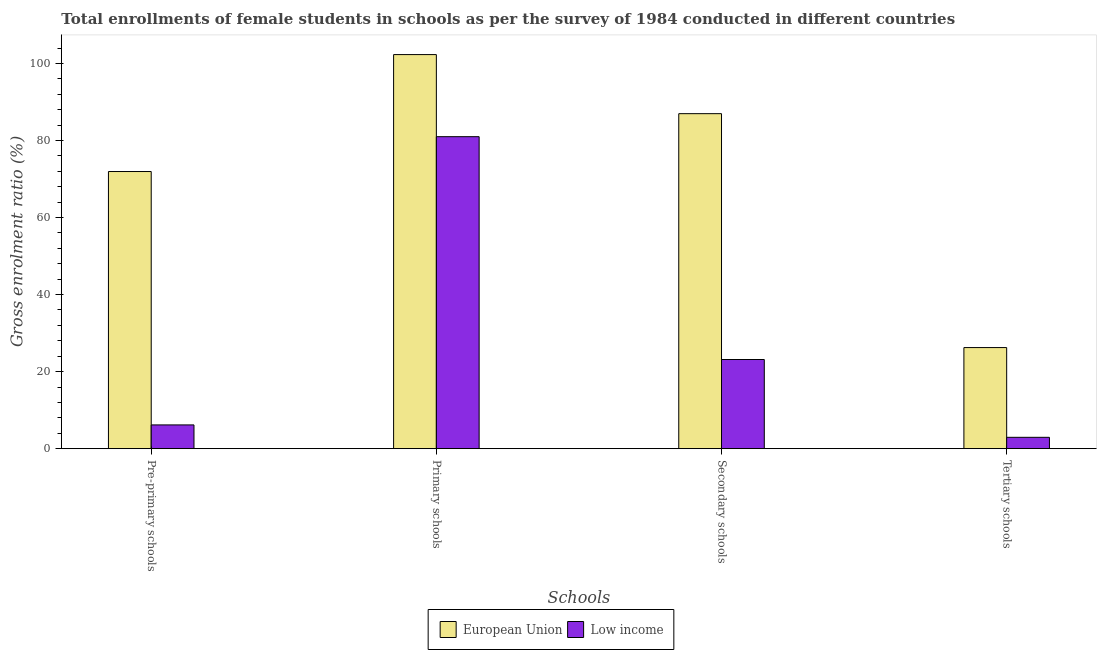Are the number of bars per tick equal to the number of legend labels?
Ensure brevity in your answer.  Yes. Are the number of bars on each tick of the X-axis equal?
Offer a terse response. Yes. What is the label of the 4th group of bars from the left?
Offer a very short reply. Tertiary schools. What is the gross enrolment ratio(female) in secondary schools in European Union?
Make the answer very short. 86.96. Across all countries, what is the maximum gross enrolment ratio(female) in tertiary schools?
Give a very brief answer. 26.24. Across all countries, what is the minimum gross enrolment ratio(female) in pre-primary schools?
Provide a short and direct response. 6.17. In which country was the gross enrolment ratio(female) in tertiary schools maximum?
Provide a short and direct response. European Union. In which country was the gross enrolment ratio(female) in secondary schools minimum?
Give a very brief answer. Low income. What is the total gross enrolment ratio(female) in primary schools in the graph?
Your response must be concise. 183.28. What is the difference between the gross enrolment ratio(female) in tertiary schools in European Union and that in Low income?
Provide a short and direct response. 23.3. What is the difference between the gross enrolment ratio(female) in pre-primary schools in European Union and the gross enrolment ratio(female) in primary schools in Low income?
Make the answer very short. -9.04. What is the average gross enrolment ratio(female) in primary schools per country?
Make the answer very short. 91.64. What is the difference between the gross enrolment ratio(female) in secondary schools and gross enrolment ratio(female) in pre-primary schools in European Union?
Offer a terse response. 15.02. What is the ratio of the gross enrolment ratio(female) in secondary schools in European Union to that in Low income?
Make the answer very short. 3.76. Is the difference between the gross enrolment ratio(female) in pre-primary schools in European Union and Low income greater than the difference between the gross enrolment ratio(female) in tertiary schools in European Union and Low income?
Offer a terse response. Yes. What is the difference between the highest and the second highest gross enrolment ratio(female) in secondary schools?
Your answer should be compact. 63.81. What is the difference between the highest and the lowest gross enrolment ratio(female) in tertiary schools?
Your response must be concise. 23.3. What does the 1st bar from the left in Primary schools represents?
Offer a terse response. European Union. Is it the case that in every country, the sum of the gross enrolment ratio(female) in pre-primary schools and gross enrolment ratio(female) in primary schools is greater than the gross enrolment ratio(female) in secondary schools?
Offer a very short reply. Yes. Are all the bars in the graph horizontal?
Give a very brief answer. No. What is the difference between two consecutive major ticks on the Y-axis?
Give a very brief answer. 20. Does the graph contain grids?
Offer a very short reply. No. Where does the legend appear in the graph?
Your answer should be very brief. Bottom center. How are the legend labels stacked?
Offer a very short reply. Horizontal. What is the title of the graph?
Provide a short and direct response. Total enrollments of female students in schools as per the survey of 1984 conducted in different countries. What is the label or title of the X-axis?
Provide a succinct answer. Schools. What is the label or title of the Y-axis?
Offer a very short reply. Gross enrolment ratio (%). What is the Gross enrolment ratio (%) of European Union in Pre-primary schools?
Ensure brevity in your answer.  71.94. What is the Gross enrolment ratio (%) in Low income in Pre-primary schools?
Ensure brevity in your answer.  6.17. What is the Gross enrolment ratio (%) in European Union in Primary schools?
Make the answer very short. 102.3. What is the Gross enrolment ratio (%) in Low income in Primary schools?
Provide a succinct answer. 80.98. What is the Gross enrolment ratio (%) of European Union in Secondary schools?
Offer a very short reply. 86.96. What is the Gross enrolment ratio (%) in Low income in Secondary schools?
Keep it short and to the point. 23.15. What is the Gross enrolment ratio (%) in European Union in Tertiary schools?
Offer a terse response. 26.24. What is the Gross enrolment ratio (%) in Low income in Tertiary schools?
Keep it short and to the point. 2.95. Across all Schools, what is the maximum Gross enrolment ratio (%) in European Union?
Ensure brevity in your answer.  102.3. Across all Schools, what is the maximum Gross enrolment ratio (%) of Low income?
Your answer should be very brief. 80.98. Across all Schools, what is the minimum Gross enrolment ratio (%) of European Union?
Your answer should be very brief. 26.24. Across all Schools, what is the minimum Gross enrolment ratio (%) of Low income?
Make the answer very short. 2.95. What is the total Gross enrolment ratio (%) in European Union in the graph?
Make the answer very short. 287.44. What is the total Gross enrolment ratio (%) of Low income in the graph?
Keep it short and to the point. 113.24. What is the difference between the Gross enrolment ratio (%) in European Union in Pre-primary schools and that in Primary schools?
Offer a terse response. -30.35. What is the difference between the Gross enrolment ratio (%) of Low income in Pre-primary schools and that in Primary schools?
Offer a very short reply. -74.82. What is the difference between the Gross enrolment ratio (%) of European Union in Pre-primary schools and that in Secondary schools?
Your answer should be very brief. -15.02. What is the difference between the Gross enrolment ratio (%) in Low income in Pre-primary schools and that in Secondary schools?
Provide a succinct answer. -16.98. What is the difference between the Gross enrolment ratio (%) in European Union in Pre-primary schools and that in Tertiary schools?
Keep it short and to the point. 45.7. What is the difference between the Gross enrolment ratio (%) of Low income in Pre-primary schools and that in Tertiary schools?
Give a very brief answer. 3.22. What is the difference between the Gross enrolment ratio (%) in European Union in Primary schools and that in Secondary schools?
Provide a short and direct response. 15.34. What is the difference between the Gross enrolment ratio (%) in Low income in Primary schools and that in Secondary schools?
Give a very brief answer. 57.84. What is the difference between the Gross enrolment ratio (%) in European Union in Primary schools and that in Tertiary schools?
Give a very brief answer. 76.05. What is the difference between the Gross enrolment ratio (%) in Low income in Primary schools and that in Tertiary schools?
Make the answer very short. 78.04. What is the difference between the Gross enrolment ratio (%) in European Union in Secondary schools and that in Tertiary schools?
Offer a terse response. 60.72. What is the difference between the Gross enrolment ratio (%) of Low income in Secondary schools and that in Tertiary schools?
Ensure brevity in your answer.  20.2. What is the difference between the Gross enrolment ratio (%) in European Union in Pre-primary schools and the Gross enrolment ratio (%) in Low income in Primary schools?
Offer a terse response. -9.04. What is the difference between the Gross enrolment ratio (%) of European Union in Pre-primary schools and the Gross enrolment ratio (%) of Low income in Secondary schools?
Provide a succinct answer. 48.8. What is the difference between the Gross enrolment ratio (%) in European Union in Pre-primary schools and the Gross enrolment ratio (%) in Low income in Tertiary schools?
Make the answer very short. 69. What is the difference between the Gross enrolment ratio (%) in European Union in Primary schools and the Gross enrolment ratio (%) in Low income in Secondary schools?
Your answer should be compact. 79.15. What is the difference between the Gross enrolment ratio (%) in European Union in Primary schools and the Gross enrolment ratio (%) in Low income in Tertiary schools?
Your answer should be very brief. 99.35. What is the difference between the Gross enrolment ratio (%) in European Union in Secondary schools and the Gross enrolment ratio (%) in Low income in Tertiary schools?
Make the answer very short. 84.01. What is the average Gross enrolment ratio (%) in European Union per Schools?
Keep it short and to the point. 71.86. What is the average Gross enrolment ratio (%) of Low income per Schools?
Provide a succinct answer. 28.31. What is the difference between the Gross enrolment ratio (%) in European Union and Gross enrolment ratio (%) in Low income in Pre-primary schools?
Offer a terse response. 65.77. What is the difference between the Gross enrolment ratio (%) of European Union and Gross enrolment ratio (%) of Low income in Primary schools?
Offer a very short reply. 21.31. What is the difference between the Gross enrolment ratio (%) of European Union and Gross enrolment ratio (%) of Low income in Secondary schools?
Your answer should be very brief. 63.81. What is the difference between the Gross enrolment ratio (%) in European Union and Gross enrolment ratio (%) in Low income in Tertiary schools?
Your response must be concise. 23.3. What is the ratio of the Gross enrolment ratio (%) of European Union in Pre-primary schools to that in Primary schools?
Provide a short and direct response. 0.7. What is the ratio of the Gross enrolment ratio (%) in Low income in Pre-primary schools to that in Primary schools?
Your answer should be very brief. 0.08. What is the ratio of the Gross enrolment ratio (%) of European Union in Pre-primary schools to that in Secondary schools?
Make the answer very short. 0.83. What is the ratio of the Gross enrolment ratio (%) in Low income in Pre-primary schools to that in Secondary schools?
Offer a terse response. 0.27. What is the ratio of the Gross enrolment ratio (%) of European Union in Pre-primary schools to that in Tertiary schools?
Your response must be concise. 2.74. What is the ratio of the Gross enrolment ratio (%) of Low income in Pre-primary schools to that in Tertiary schools?
Give a very brief answer. 2.09. What is the ratio of the Gross enrolment ratio (%) in European Union in Primary schools to that in Secondary schools?
Ensure brevity in your answer.  1.18. What is the ratio of the Gross enrolment ratio (%) of Low income in Primary schools to that in Secondary schools?
Your answer should be very brief. 3.5. What is the ratio of the Gross enrolment ratio (%) of European Union in Primary schools to that in Tertiary schools?
Offer a very short reply. 3.9. What is the ratio of the Gross enrolment ratio (%) of Low income in Primary schools to that in Tertiary schools?
Your answer should be compact. 27.49. What is the ratio of the Gross enrolment ratio (%) of European Union in Secondary schools to that in Tertiary schools?
Give a very brief answer. 3.31. What is the ratio of the Gross enrolment ratio (%) in Low income in Secondary schools to that in Tertiary schools?
Your answer should be very brief. 7.86. What is the difference between the highest and the second highest Gross enrolment ratio (%) in European Union?
Ensure brevity in your answer.  15.34. What is the difference between the highest and the second highest Gross enrolment ratio (%) in Low income?
Provide a succinct answer. 57.84. What is the difference between the highest and the lowest Gross enrolment ratio (%) in European Union?
Offer a very short reply. 76.05. What is the difference between the highest and the lowest Gross enrolment ratio (%) in Low income?
Ensure brevity in your answer.  78.04. 